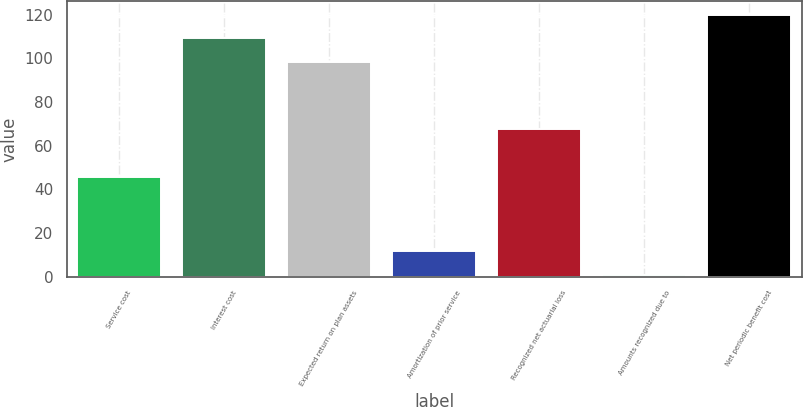<chart> <loc_0><loc_0><loc_500><loc_500><bar_chart><fcel>Service cost<fcel>Interest cost<fcel>Expected return on plan assets<fcel>Amortization of prior service<fcel>Recognized net actuarial loss<fcel>Amounts recognized due to<fcel>Net periodic benefit cost<nl><fcel>45.6<fcel>109.26<fcel>98.4<fcel>11.76<fcel>67.6<fcel>0.9<fcel>120.12<nl></chart> 